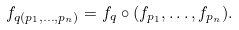<formula> <loc_0><loc_0><loc_500><loc_500>f _ { q ( p _ { 1 } , \dots , p _ { n } ) } = f _ { q } \circ ( f _ { p _ { 1 } } , \dots , f _ { p _ { n } } ) .</formula> 